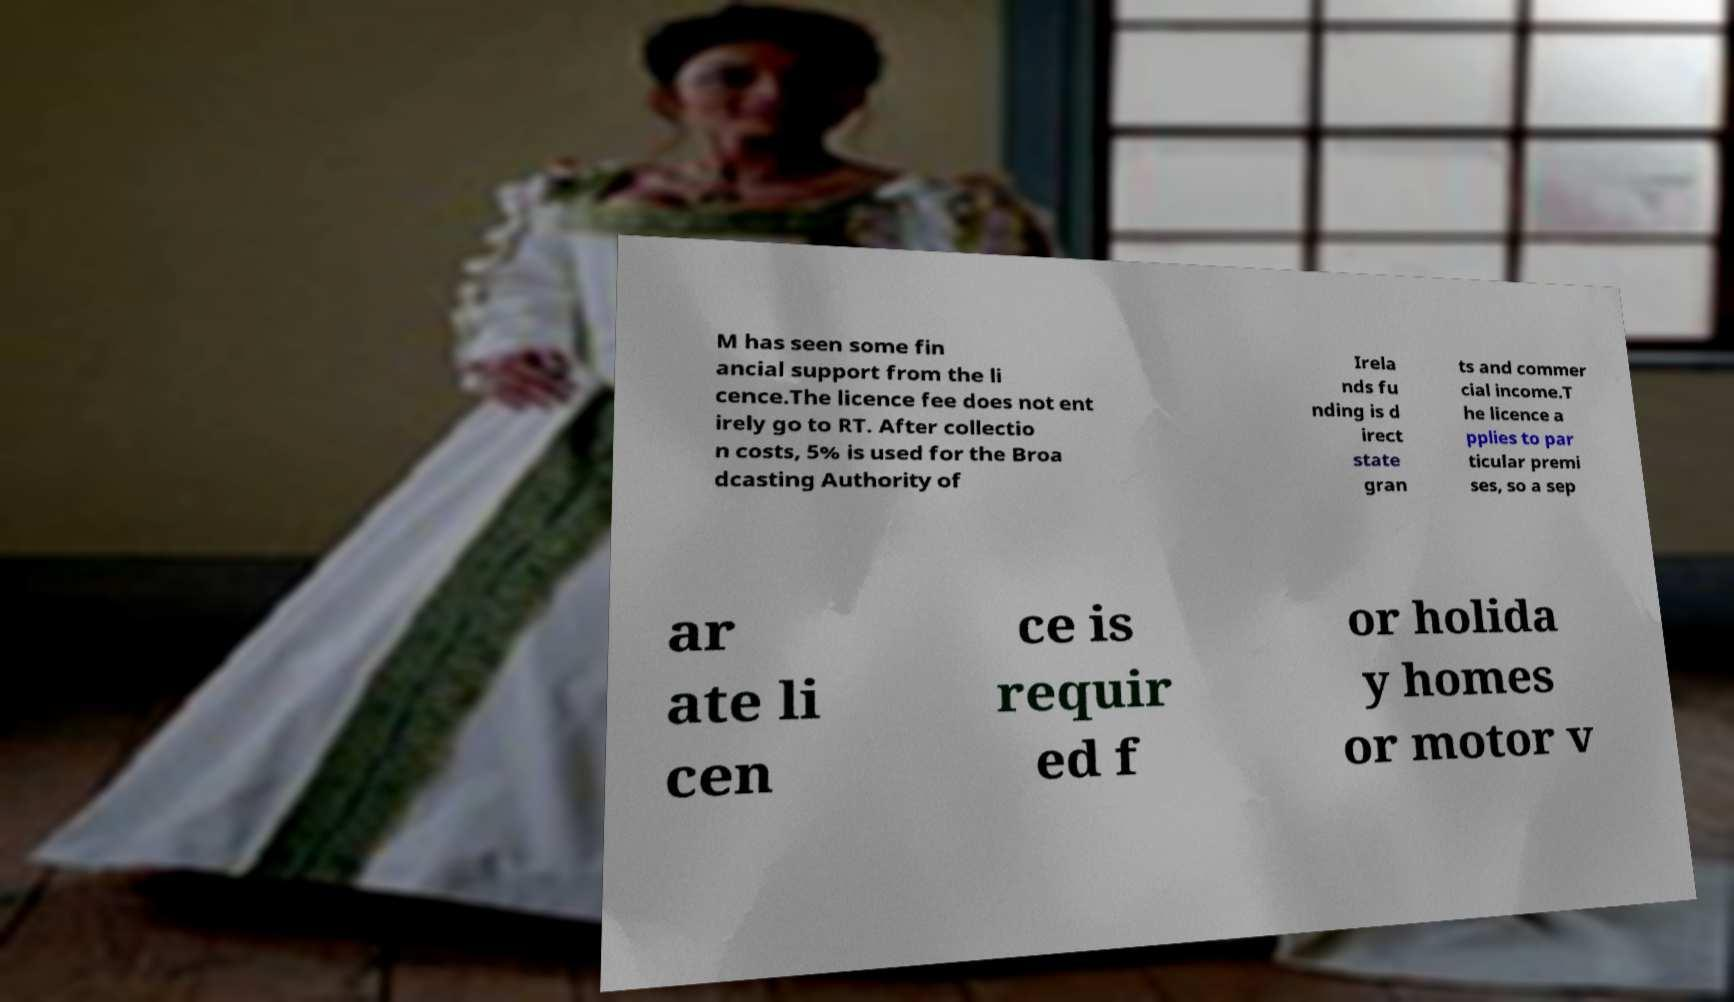I need the written content from this picture converted into text. Can you do that? M has seen some fin ancial support from the li cence.The licence fee does not ent irely go to RT. After collectio n costs, 5% is used for the Broa dcasting Authority of Irela nds fu nding is d irect state gran ts and commer cial income.T he licence a pplies to par ticular premi ses, so a sep ar ate li cen ce is requir ed f or holida y homes or motor v 